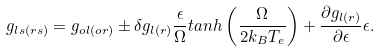Convert formula to latex. <formula><loc_0><loc_0><loc_500><loc_500>g _ { l s ( r s ) } = g _ { o l ( o r ) } \pm \delta g _ { l ( r ) } \frac { \epsilon } { \Omega } t a n h \left ( \frac { \Omega } { 2 k _ { B } T _ { e } } \right ) + \frac { \partial g _ { l ( r ) } } { \partial \epsilon } \epsilon .</formula> 